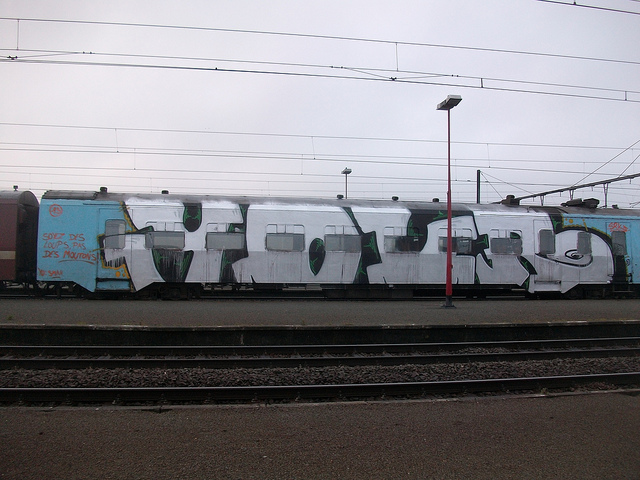<image>What graffiti is on the train? I don't know what graffiti is on the train. It may contain words, letters or sentences like 'in your heart'. What is graffiti on the train? I am not sure what the graffiti on the train is. It could be 'hour', 'molo', 'hole', 'train car', 'molar', 'ghouls', 'to', or 'white'. What graffiti is on the train? I don't know what graffiti is on the train. It can be seen words, void or white. What is graffiti on the train? I am not sure what graffiti is on the train. It can be seen 'hour', 'molo', 'hole', 'train car', 'molar', 'ghouls', 'to', 'white' or 'not sure'. 